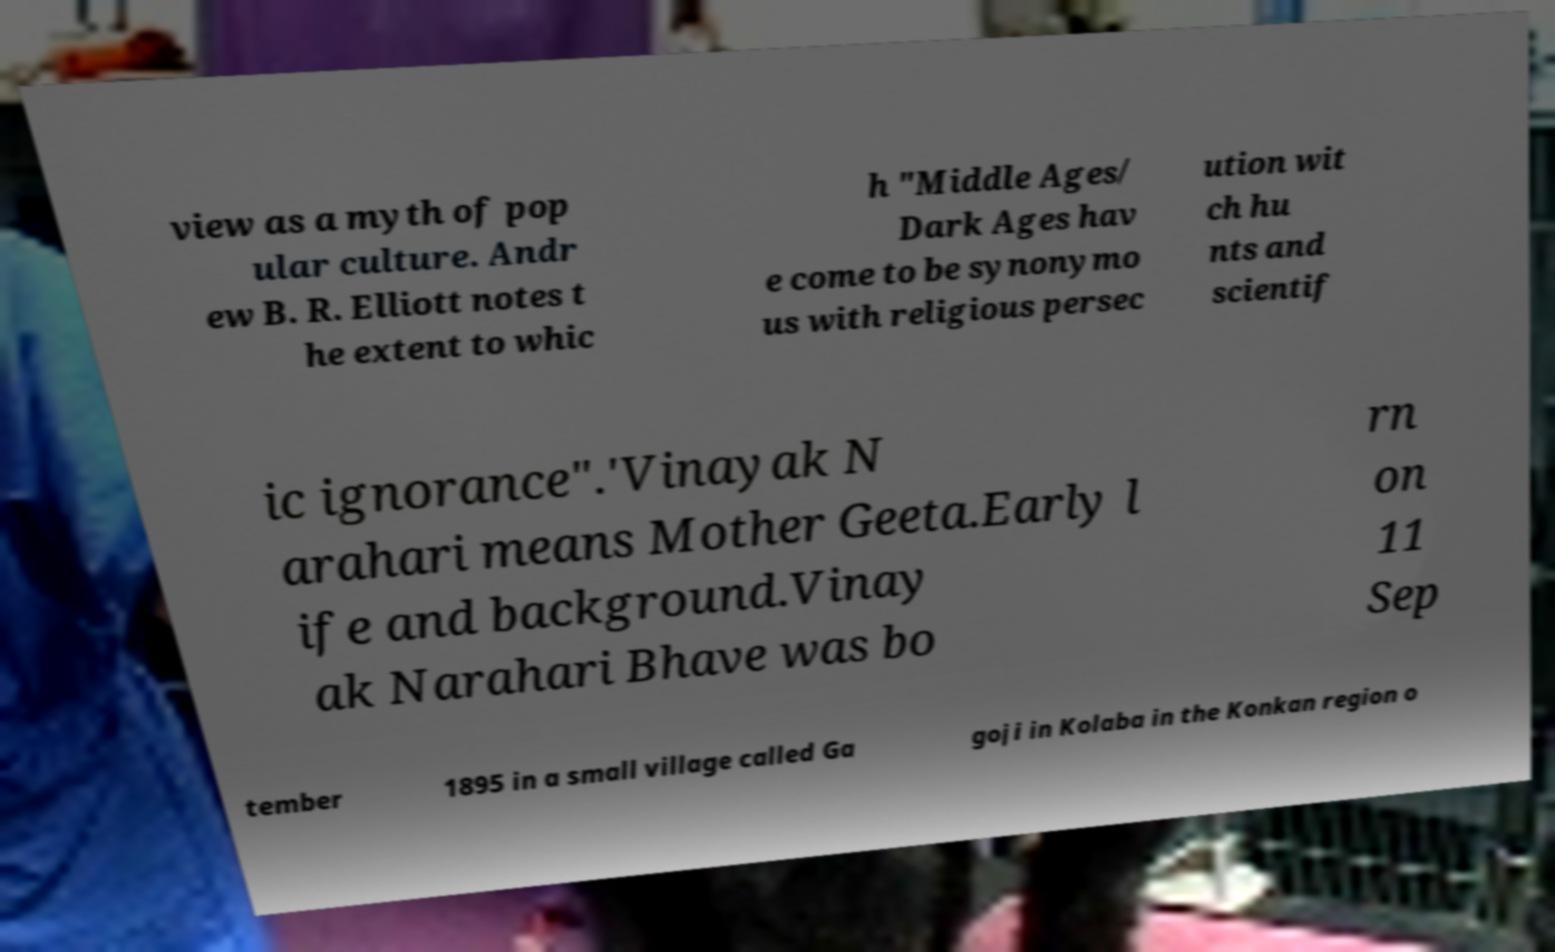What messages or text are displayed in this image? I need them in a readable, typed format. view as a myth of pop ular culture. Andr ew B. R. Elliott notes t he extent to whic h "Middle Ages/ Dark Ages hav e come to be synonymo us with religious persec ution wit ch hu nts and scientif ic ignorance".'Vinayak N arahari means Mother Geeta.Early l ife and background.Vinay ak Narahari Bhave was bo rn on 11 Sep tember 1895 in a small village called Ga goji in Kolaba in the Konkan region o 